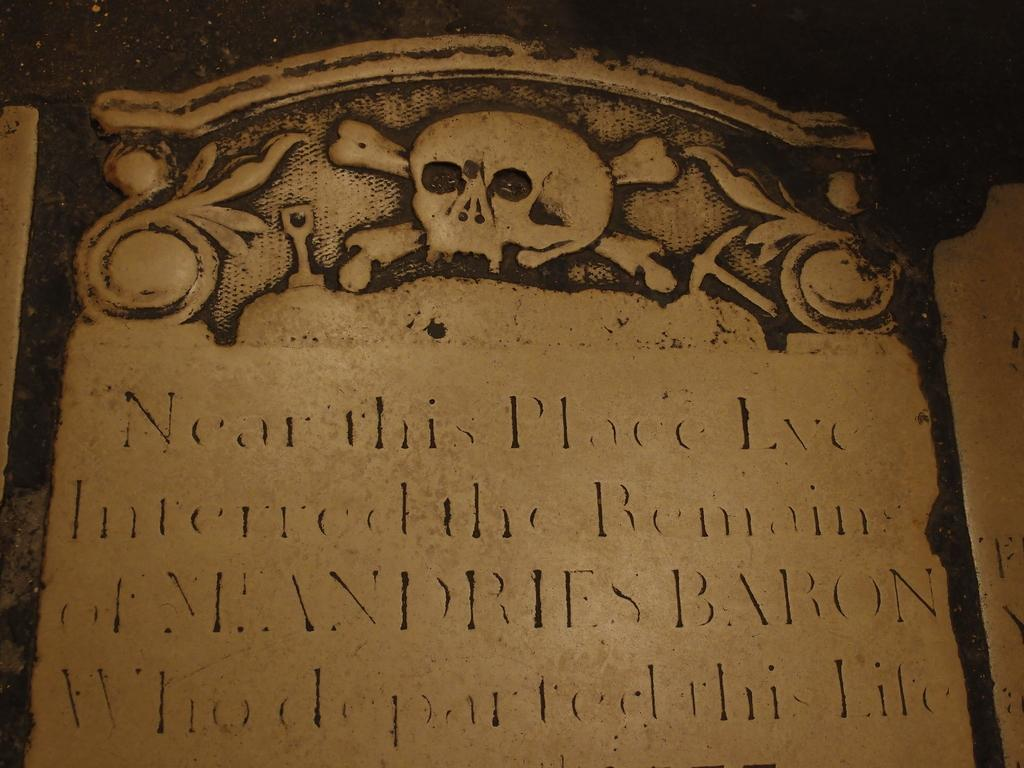What is the main subject of the image? The main subject of the image is a stone carving. Can you describe the colors of the stone carving? The stone carving has black and brown colors. Is there any text or symbols on the stone carving? Yes, there is writing on the stone carving. How many snails can be seen crawling on the stone carving in the image? There are no snails present on the stone carving in the image. What type of authority figure is depicted in the stone carving? The stone carving does not depict any authority figure; it only has writing and colors. 